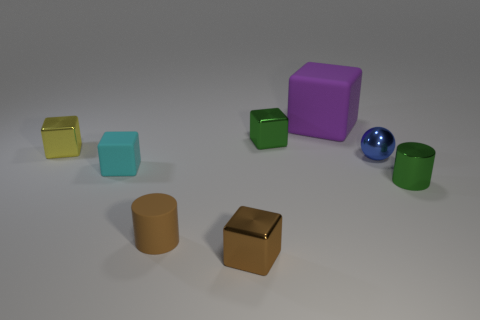Subtract 1 blocks. How many blocks are left? 4 Add 2 red matte cubes. How many objects exist? 10 Subtract all spheres. How many objects are left? 7 Add 5 brown metal blocks. How many brown metal blocks are left? 6 Add 6 big matte cubes. How many big matte cubes exist? 7 Subtract 1 green cylinders. How many objects are left? 7 Subtract all tiny brown metallic things. Subtract all big matte cubes. How many objects are left? 6 